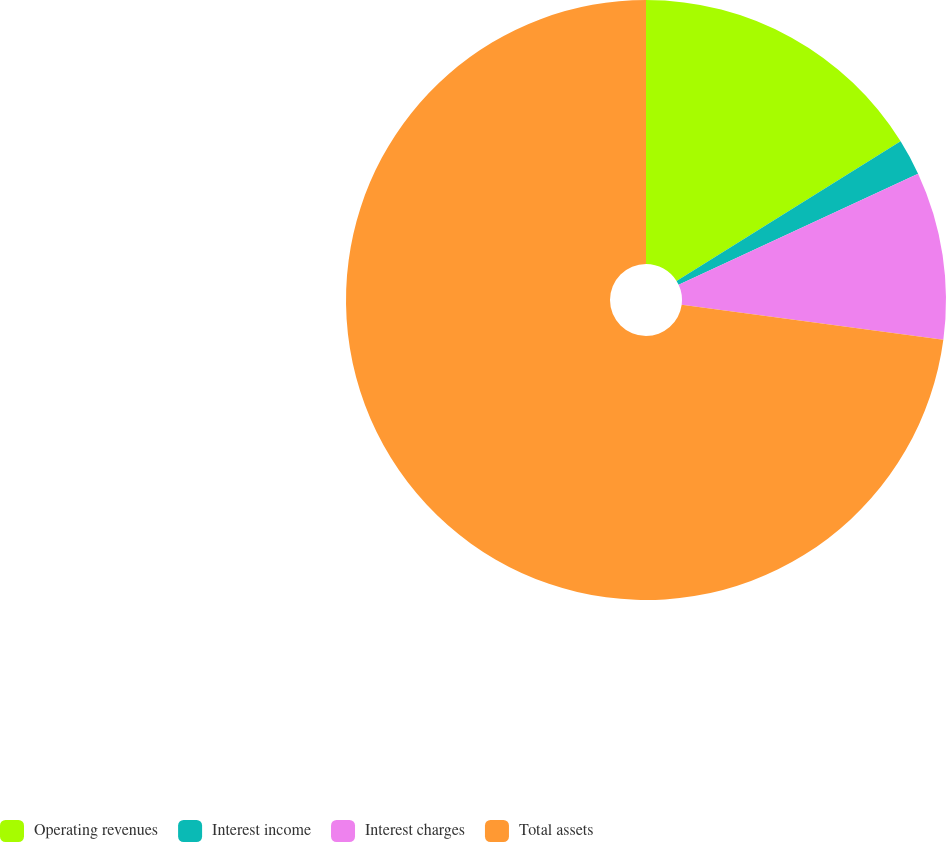Convert chart. <chart><loc_0><loc_0><loc_500><loc_500><pie_chart><fcel>Operating revenues<fcel>Interest income<fcel>Interest charges<fcel>Total assets<nl><fcel>16.13%<fcel>1.95%<fcel>9.04%<fcel>72.88%<nl></chart> 